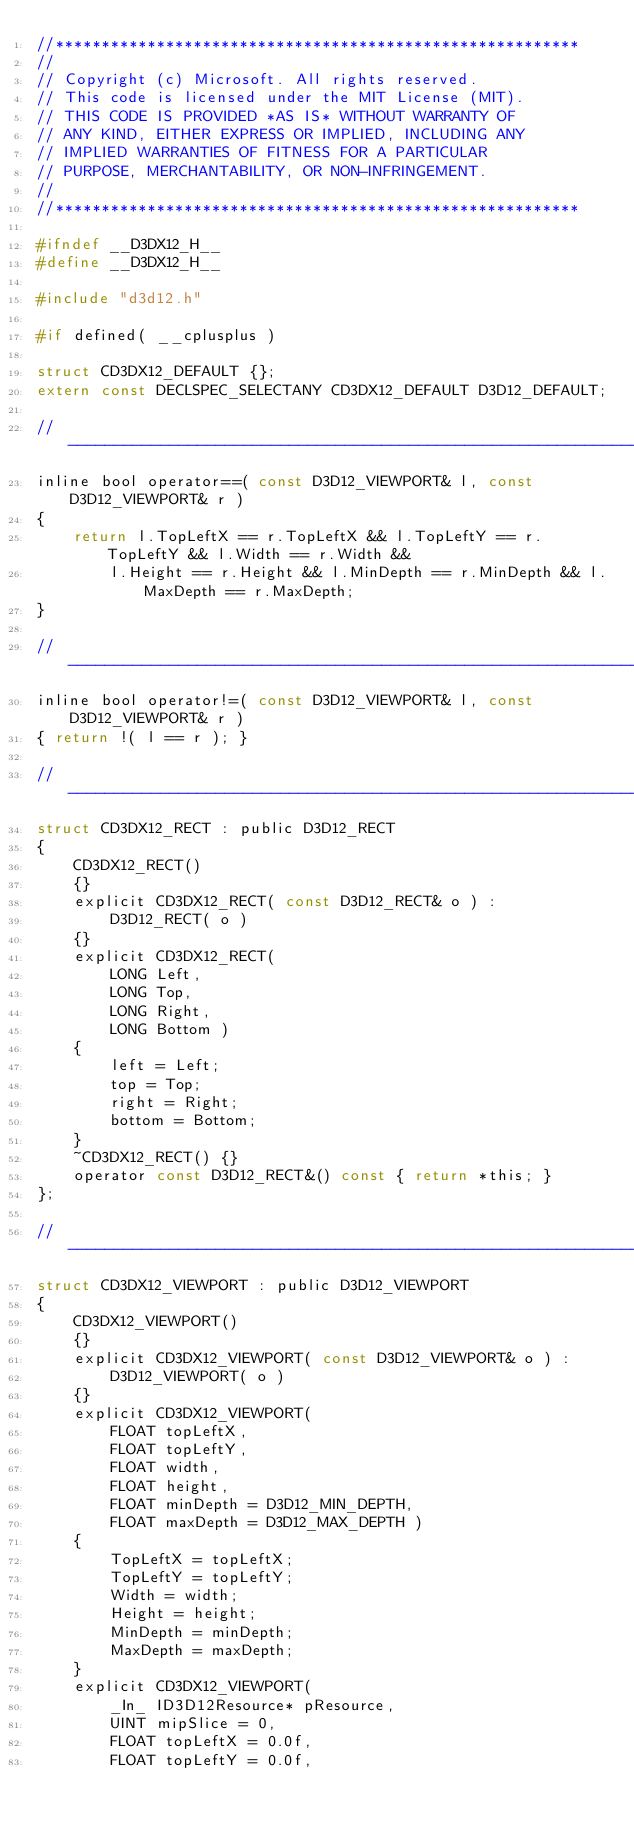<code> <loc_0><loc_0><loc_500><loc_500><_C_>//*********************************************************
//
// Copyright (c) Microsoft. All rights reserved.
// This code is licensed under the MIT License (MIT).
// THIS CODE IS PROVIDED *AS IS* WITHOUT WARRANTY OF
// ANY KIND, EITHER EXPRESS OR IMPLIED, INCLUDING ANY
// IMPLIED WARRANTIES OF FITNESS FOR A PARTICULAR
// PURPOSE, MERCHANTABILITY, OR NON-INFRINGEMENT.
//
//*********************************************************

#ifndef __D3DX12_H__
#define __D3DX12_H__

#include "d3d12.h"

#if defined( __cplusplus )

struct CD3DX12_DEFAULT {};
extern const DECLSPEC_SELECTANY CD3DX12_DEFAULT D3D12_DEFAULT;

//------------------------------------------------------------------------------------------------
inline bool operator==( const D3D12_VIEWPORT& l, const D3D12_VIEWPORT& r )
{
    return l.TopLeftX == r.TopLeftX && l.TopLeftY == r.TopLeftY && l.Width == r.Width &&
        l.Height == r.Height && l.MinDepth == r.MinDepth && l.MaxDepth == r.MaxDepth;
}

//------------------------------------------------------------------------------------------------
inline bool operator!=( const D3D12_VIEWPORT& l, const D3D12_VIEWPORT& r )
{ return !( l == r ); }

//------------------------------------------------------------------------------------------------
struct CD3DX12_RECT : public D3D12_RECT
{
    CD3DX12_RECT()
    {}
    explicit CD3DX12_RECT( const D3D12_RECT& o ) :
        D3D12_RECT( o )
    {}
    explicit CD3DX12_RECT(
        LONG Left,
        LONG Top,
        LONG Right,
        LONG Bottom )
    {
        left = Left;
        top = Top;
        right = Right;
        bottom = Bottom;
    }
    ~CD3DX12_RECT() {}
    operator const D3D12_RECT&() const { return *this; }
};

//------------------------------------------------------------------------------------------------
struct CD3DX12_VIEWPORT : public D3D12_VIEWPORT
{
    CD3DX12_VIEWPORT()
    {}
    explicit CD3DX12_VIEWPORT( const D3D12_VIEWPORT& o ) :
        D3D12_VIEWPORT( o )
    {}
    explicit CD3DX12_VIEWPORT(
        FLOAT topLeftX,
        FLOAT topLeftY,
        FLOAT width,
        FLOAT height,
        FLOAT minDepth = D3D12_MIN_DEPTH,
        FLOAT maxDepth = D3D12_MAX_DEPTH )
    {
        TopLeftX = topLeftX;
        TopLeftY = topLeftY;
        Width = width;
        Height = height;
        MinDepth = minDepth;
        MaxDepth = maxDepth;
    }
    explicit CD3DX12_VIEWPORT(
        _In_ ID3D12Resource* pResource,
        UINT mipSlice = 0,
        FLOAT topLeftX = 0.0f,
        FLOAT topLeftY = 0.0f,</code> 